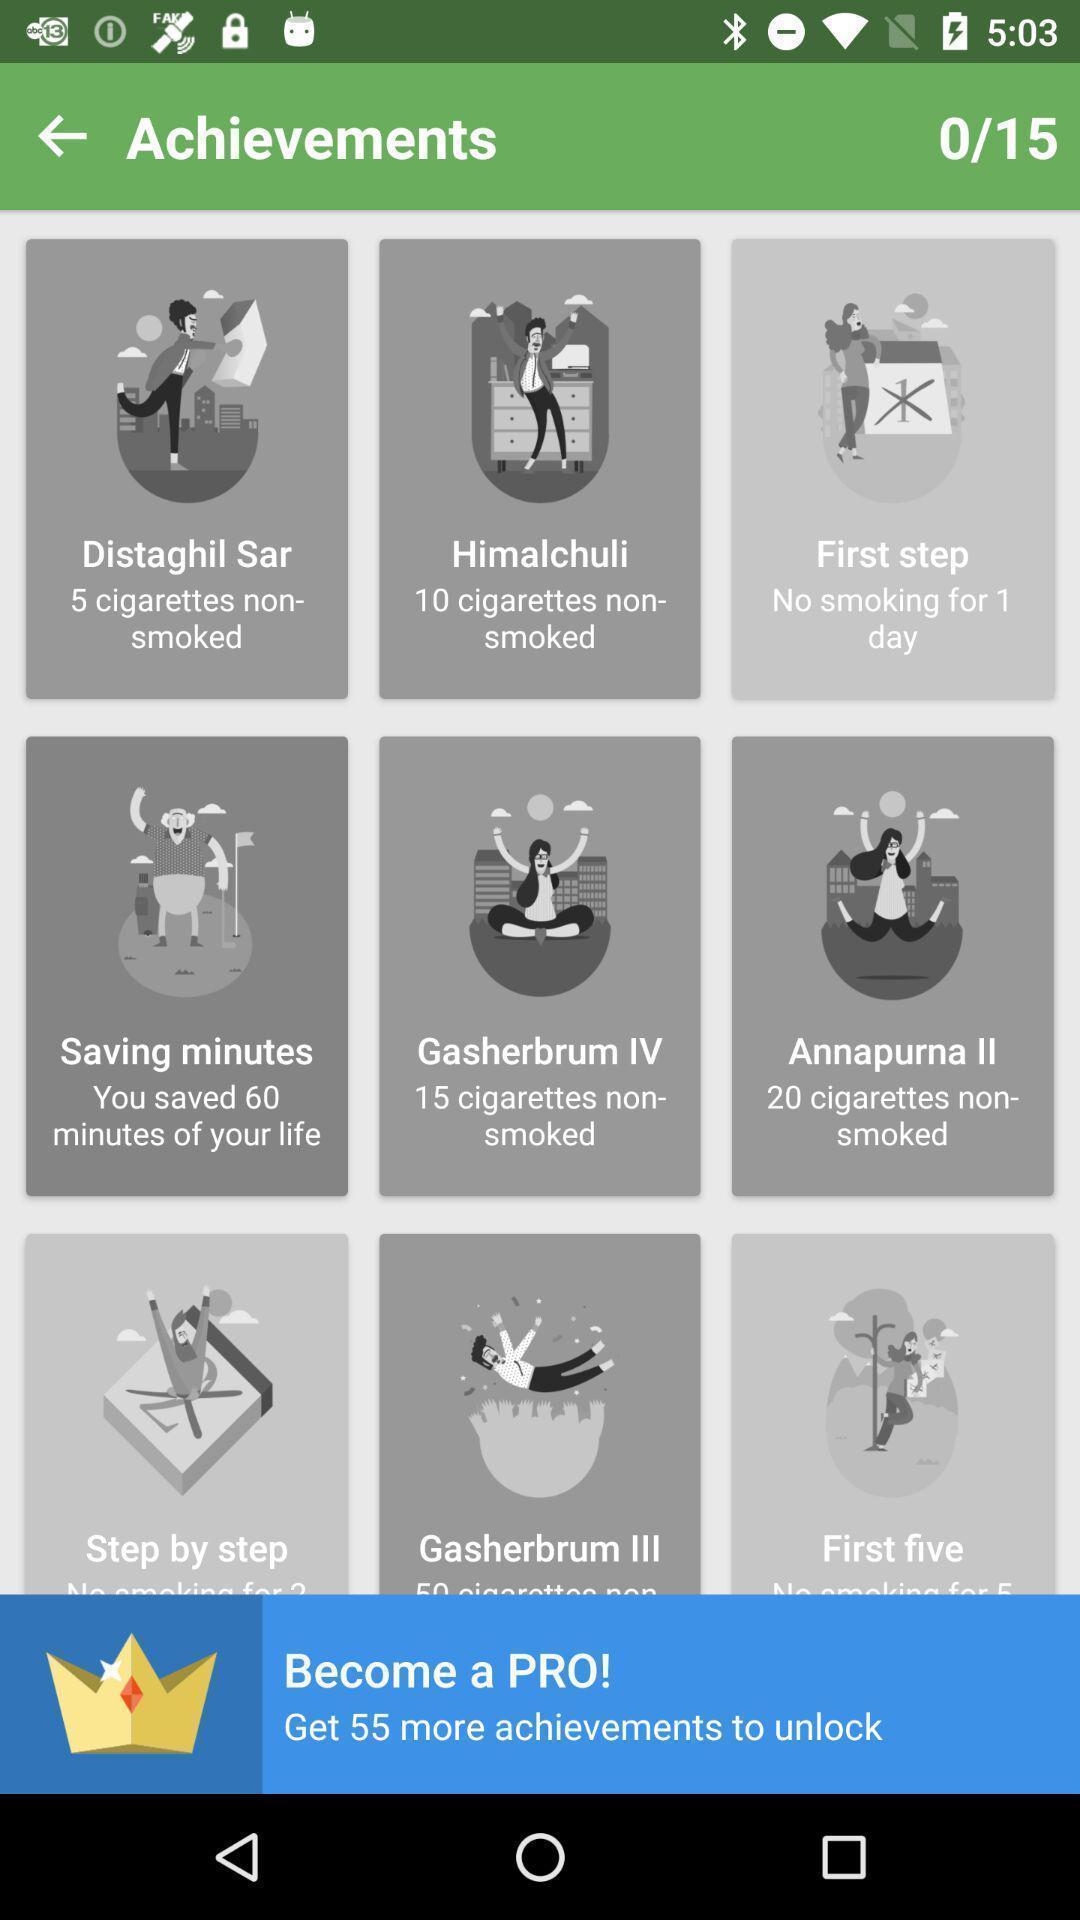Summarize the information in this screenshot. Page showing achievements. 